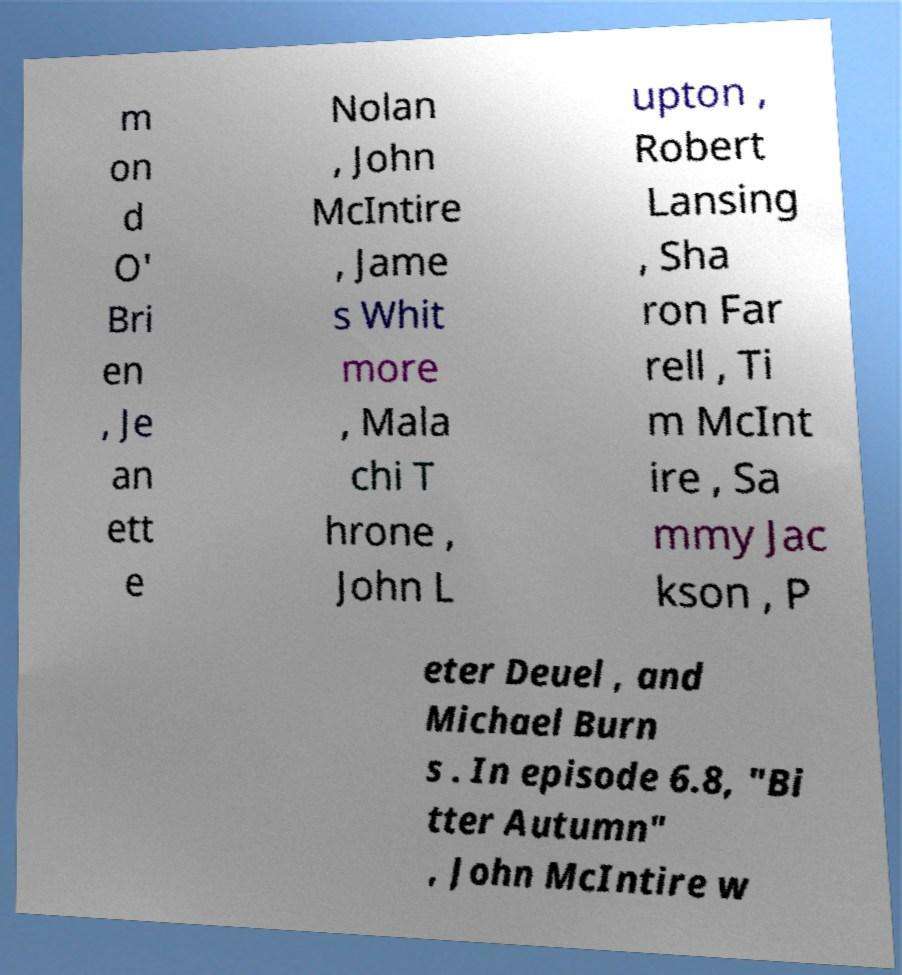I need the written content from this picture converted into text. Can you do that? m on d O' Bri en , Je an ett e Nolan , John McIntire , Jame s Whit more , Mala chi T hrone , John L upton , Robert Lansing , Sha ron Far rell , Ti m McInt ire , Sa mmy Jac kson , P eter Deuel , and Michael Burn s . In episode 6.8, "Bi tter Autumn" , John McIntire w 